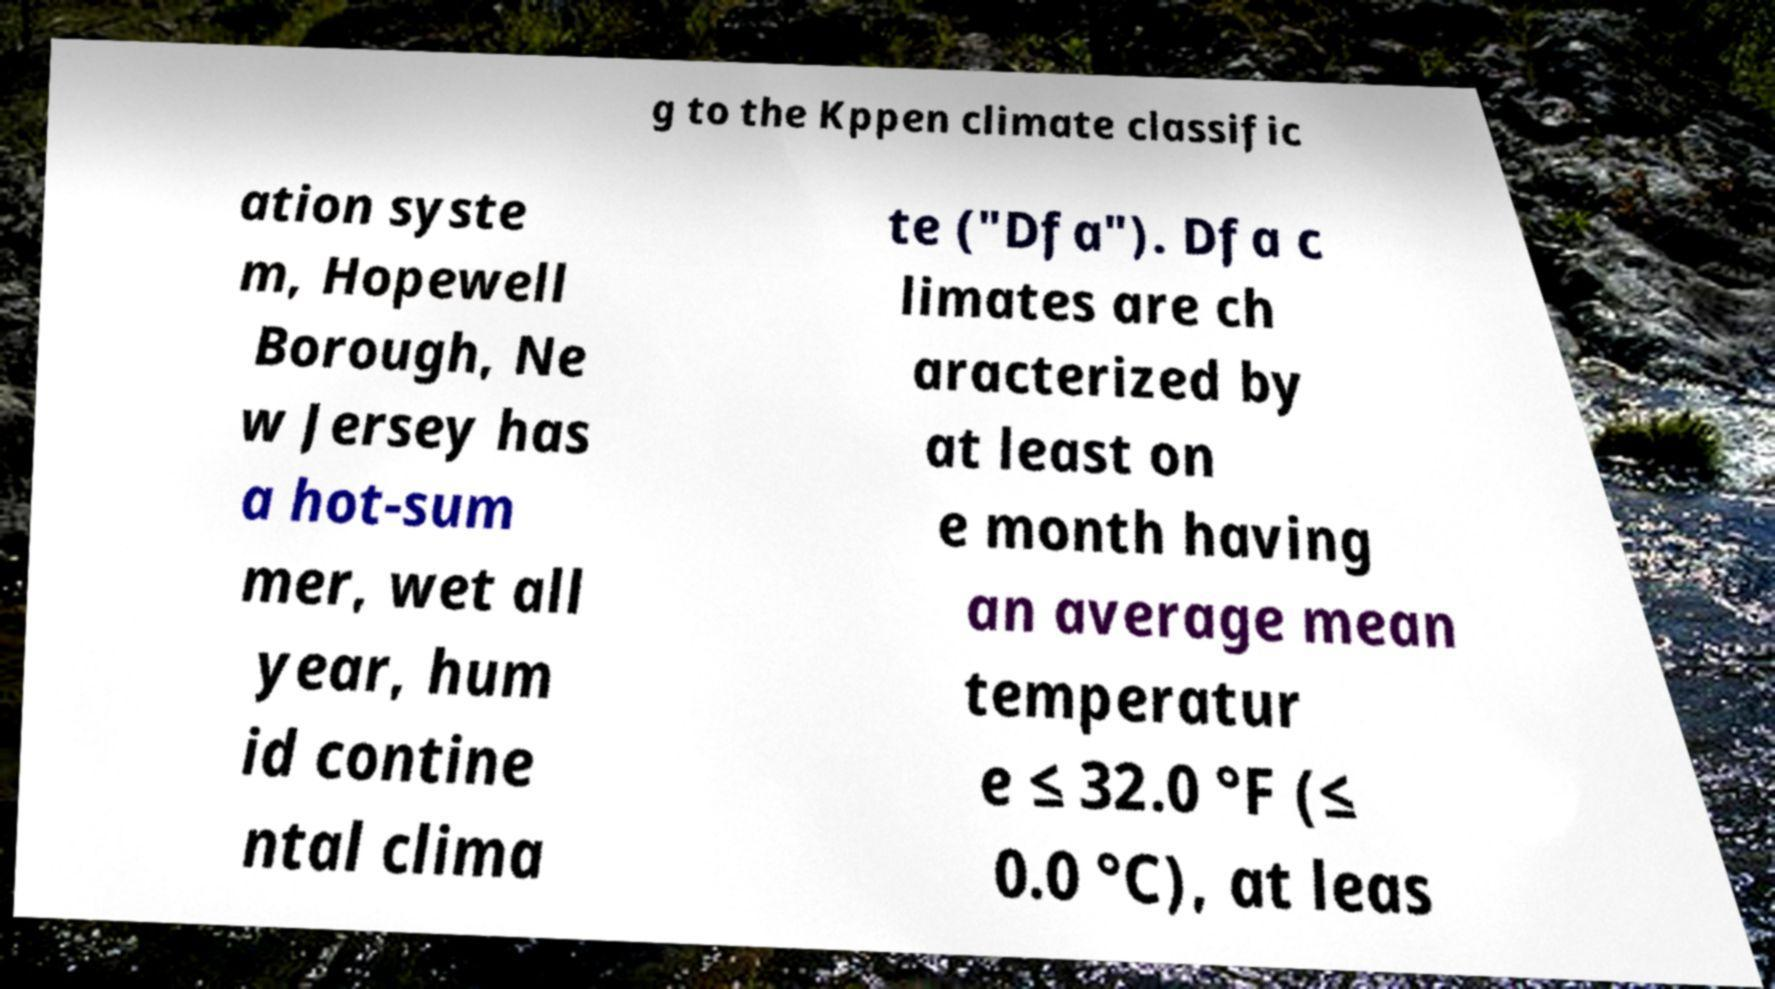Can you read and provide the text displayed in the image?This photo seems to have some interesting text. Can you extract and type it out for me? g to the Kppen climate classific ation syste m, Hopewell Borough, Ne w Jersey has a hot-sum mer, wet all year, hum id contine ntal clima te ("Dfa"). Dfa c limates are ch aracterized by at least on e month having an average mean temperatur e ≤ 32.0 °F (≤ 0.0 °C), at leas 